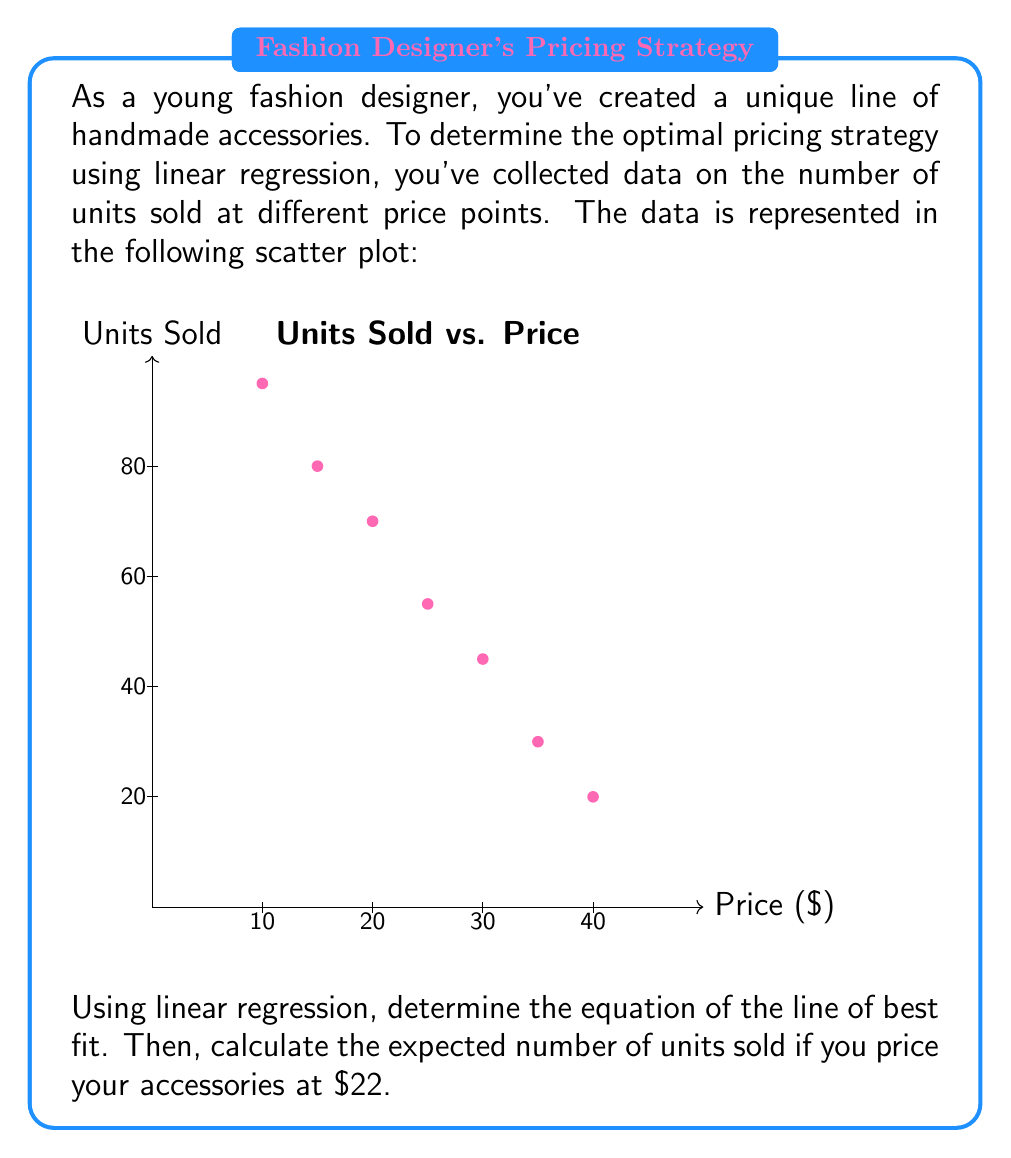Give your solution to this math problem. To solve this problem, we'll follow these steps:

1. Calculate the slope and y-intercept of the line of best fit using linear regression.
2. Form the equation of the line.
3. Use the equation to predict sales at $22.

Step 1: Calculate slope (m) and y-intercept (b)

For linear regression, we use these formulas:

$$ m = \frac{n\sum xy - \sum x \sum y}{n\sum x^2 - (\sum x)^2} $$
$$ b = \frac{\sum y - m\sum x}{n} $$

Where n is the number of data points.

Let's calculate the necessary sums:
$n = 7$
$\sum x = 175$
$\sum y = 395$
$\sum xy = 7075$
$\sum x^2 = 5125$

Plugging into the slope formula:
$$ m = \frac{7(7075) - 175(395)}{7(5125) - 175^2} = -2.5 $$

For the y-intercept:
$$ b = \frac{395 - (-2.5)(175)}{7} = 118.75 $$

Step 2: Form the equation of the line

The equation of a line is $y = mx + b$. Substituting our values:

$$ y = -2.5x + 118.75 $$

Step 3: Predict sales at $22

To find the expected number of units sold at $22, we substitute x = 22 into our equation:

$$ y = -2.5(22) + 118.75 = 63.75 $$

Therefore, we expect to sell approximately 64 units (rounding to the nearest whole number) if the accessories are priced at $22.
Answer: 64 units 